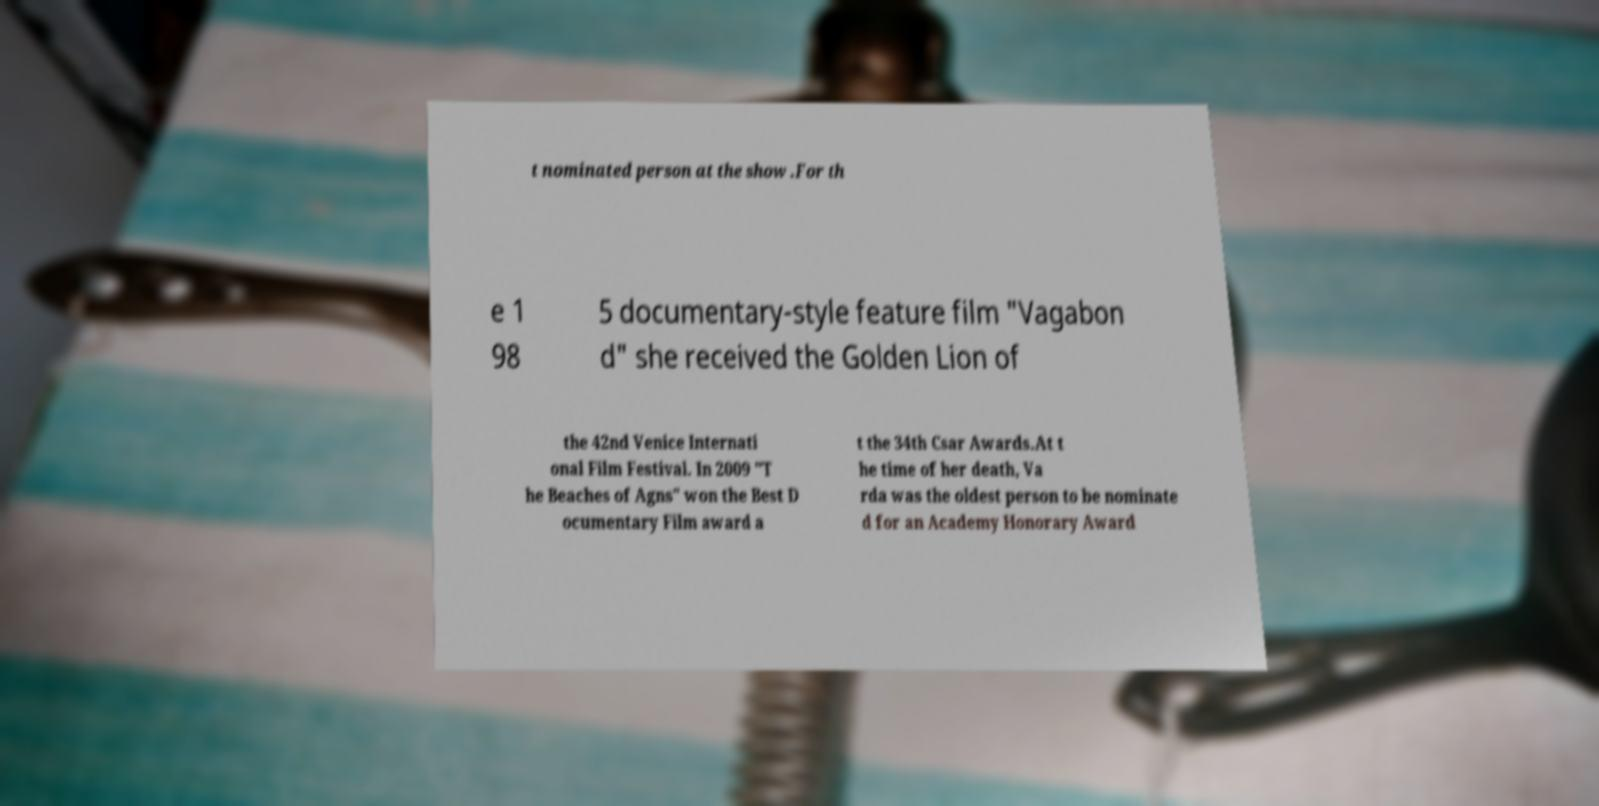There's text embedded in this image that I need extracted. Can you transcribe it verbatim? t nominated person at the show .For th e 1 98 5 documentary-style feature film "Vagabon d" she received the Golden Lion of the 42nd Venice Internati onal Film Festival. In 2009 "T he Beaches of Agns" won the Best D ocumentary Film award a t the 34th Csar Awards.At t he time of her death, Va rda was the oldest person to be nominate d for an Academy Honorary Award 